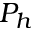Convert formula to latex. <formula><loc_0><loc_0><loc_500><loc_500>P _ { h }</formula> 